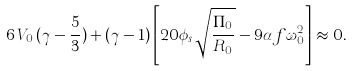<formula> <loc_0><loc_0><loc_500><loc_500>6 \, V _ { 0 } \, ( \gamma - \frac { 5 } { 3 } ) + ( \gamma - 1 ) \left [ 2 0 \phi _ { s } \sqrt { \frac { \Pi _ { 0 } } { R _ { 0 } } } - 9 \alpha f \omega _ { 0 } ^ { 2 } \right ] \approx 0 .</formula> 